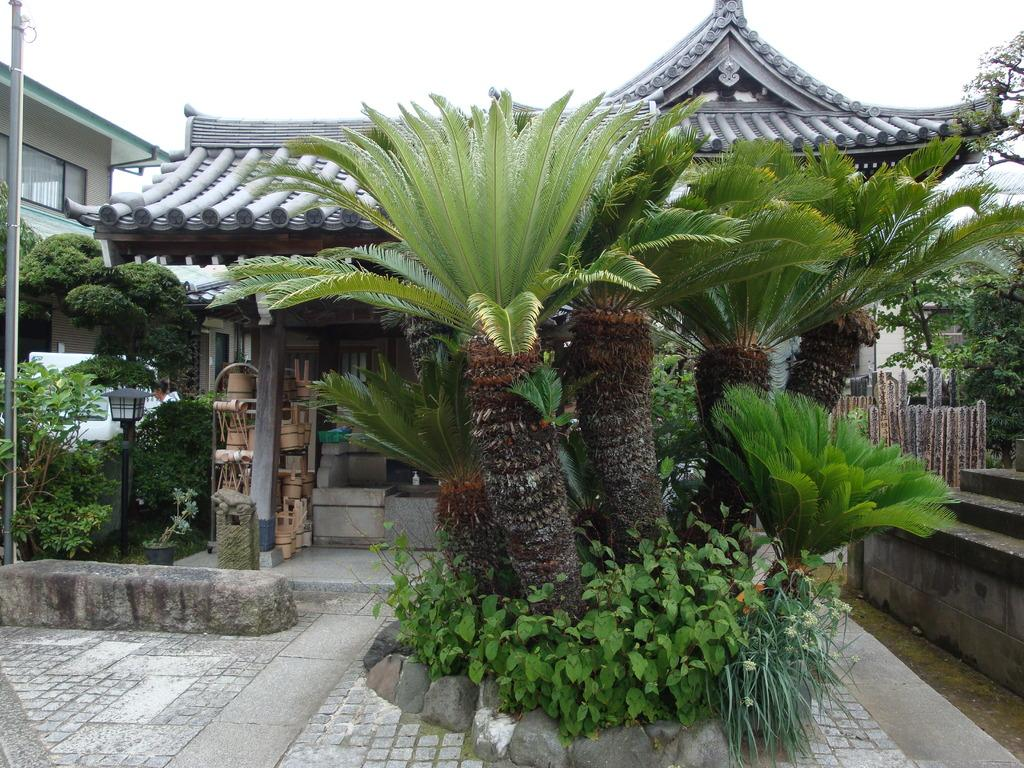What type of natural elements are in the middle of the image? There are plants and trees in the middle of the image. What type of man-made structures can be seen in the background of the image? There are buildings in the background of the image. What is visible at the top of the image? The sky is visible at the top of the image. What type of dust can be seen on the leaves of the plants in the image? There is no dust visible on the leaves of the plants in the image. What type of weather can be inferred from the image? The image does not provide enough information to determine the weather. 